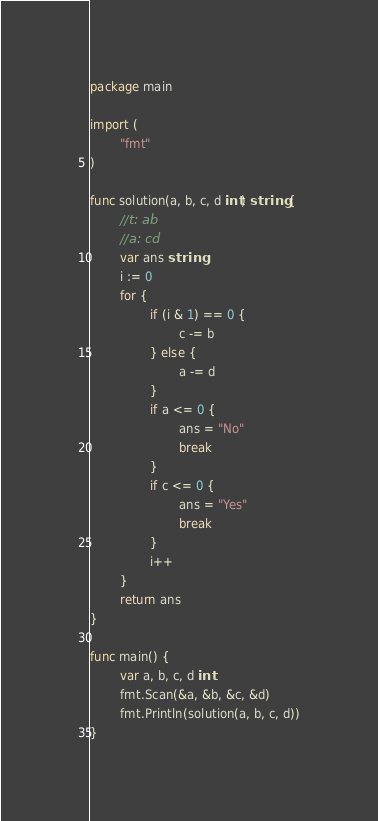<code> <loc_0><loc_0><loc_500><loc_500><_Go_>package main

import (
        "fmt"
)

func solution(a, b, c, d int) string {
        //t: ab
        //a: cd
        var ans string
        i := 0
        for {
                if (i & 1) == 0 {
                        c -= b
                } else {
                        a -= d
                }
                if a <= 0 {
                        ans = "No"
                        break
                }
                if c <= 0 {
                        ans = "Yes"
                        break
                }
                i++
        }
        return ans
}

func main() {
        var a, b, c, d int
        fmt.Scan(&a, &b, &c, &d)
        fmt.Println(solution(a, b, c, d))
}</code> 